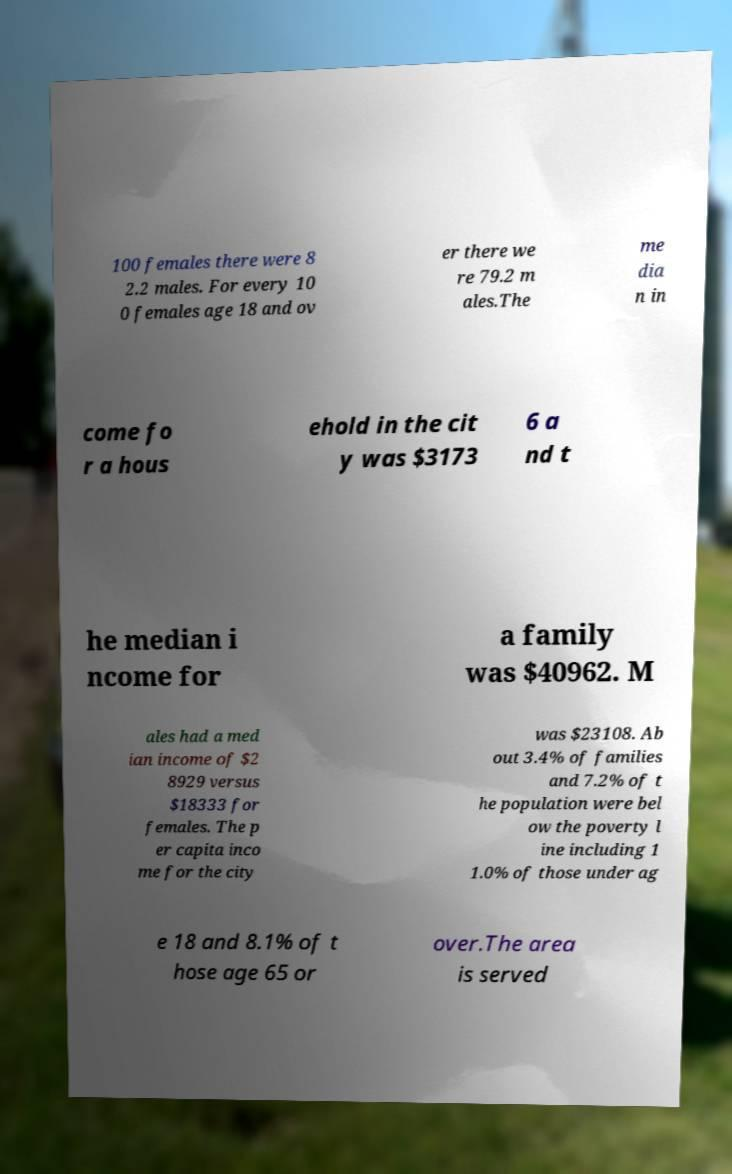There's text embedded in this image that I need extracted. Can you transcribe it verbatim? 100 females there were 8 2.2 males. For every 10 0 females age 18 and ov er there we re 79.2 m ales.The me dia n in come fo r a hous ehold in the cit y was $3173 6 a nd t he median i ncome for a family was $40962. M ales had a med ian income of $2 8929 versus $18333 for females. The p er capita inco me for the city was $23108. Ab out 3.4% of families and 7.2% of t he population were bel ow the poverty l ine including 1 1.0% of those under ag e 18 and 8.1% of t hose age 65 or over.The area is served 